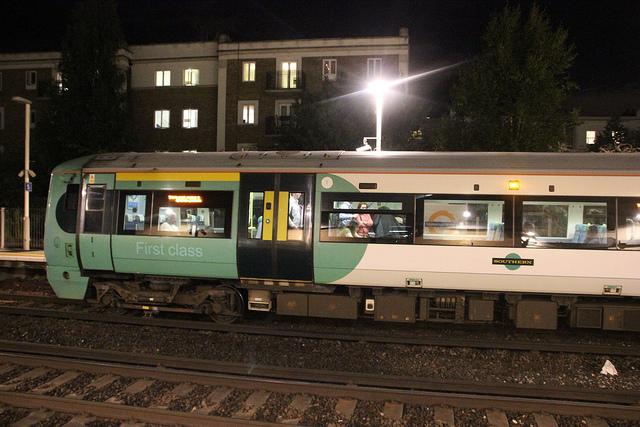Are the lights on in the building?
Be succinct. Yes. Where was the picture taken of the train?
Concise answer only. Train station. Is this a passenger train?
Quick response, please. Yes. Is it day time?
Write a very short answer. No. What color are the doors on the train?
Write a very short answer. Black. Do the doors have windows?
Short answer required. Yes. 